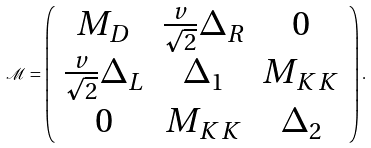Convert formula to latex. <formula><loc_0><loc_0><loc_500><loc_500>\mathcal { M } = \left ( \begin{array} { c c c } M _ { D } & \frac { v } { \sqrt { 2 } } \Delta _ { R } & 0 \\ \frac { v } { \sqrt { 2 } } \Delta _ { L } & \Delta _ { 1 } & M _ { K K } \\ 0 & M _ { K K } & \Delta _ { 2 } \end{array} \right ) .</formula> 